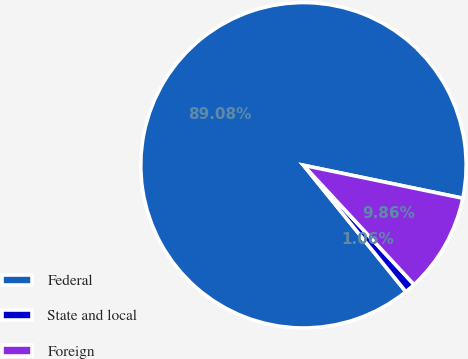Convert chart to OTSL. <chart><loc_0><loc_0><loc_500><loc_500><pie_chart><fcel>Federal<fcel>State and local<fcel>Foreign<nl><fcel>89.07%<fcel>1.06%<fcel>9.86%<nl></chart> 